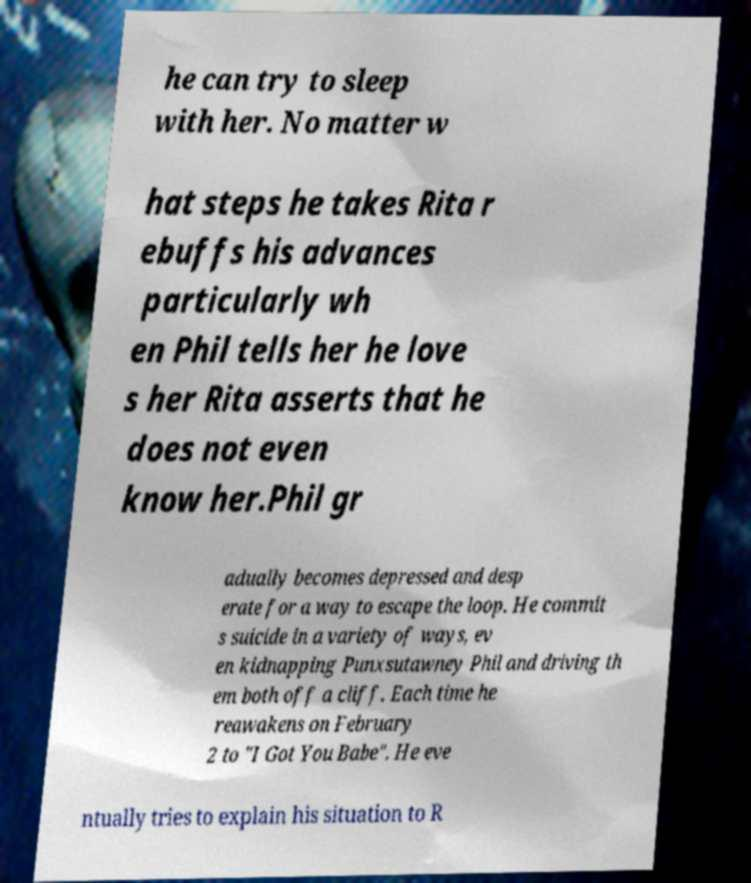Please read and relay the text visible in this image. What does it say? he can try to sleep with her. No matter w hat steps he takes Rita r ebuffs his advances particularly wh en Phil tells her he love s her Rita asserts that he does not even know her.Phil gr adually becomes depressed and desp erate for a way to escape the loop. He commit s suicide in a variety of ways, ev en kidnapping Punxsutawney Phil and driving th em both off a cliff. Each time he reawakens on February 2 to "I Got You Babe". He eve ntually tries to explain his situation to R 